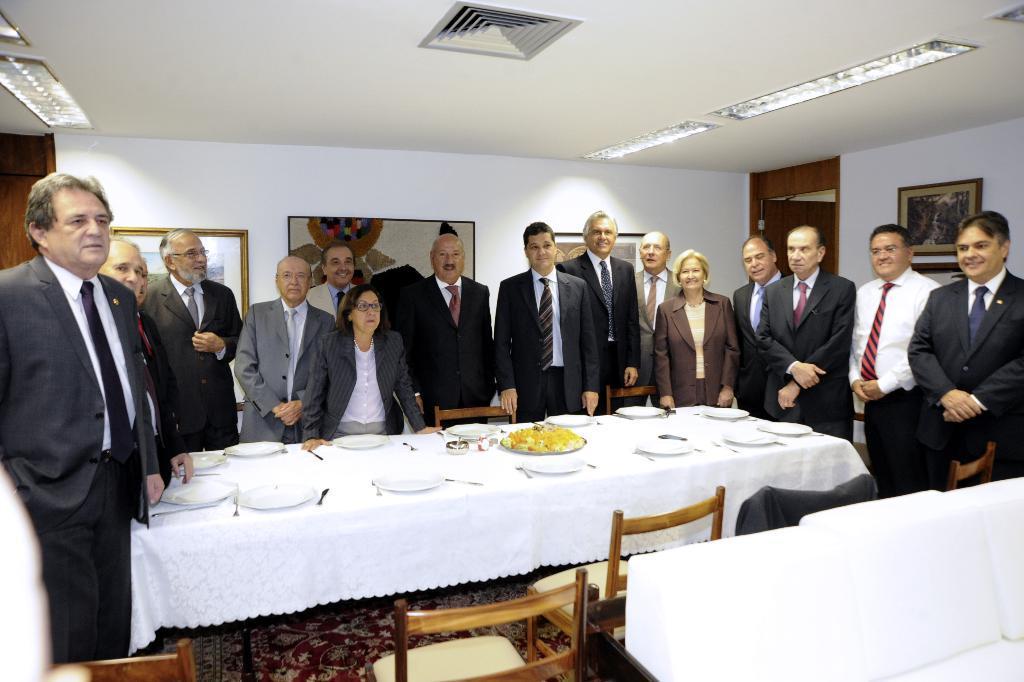Can you describe this image briefly? In the picture we can find a group of people near the table and chairs. In the background we can find a wall, a painting, photo frames. In the ceiling we can find a lights. People who are standing are wearing a blazers, ties and shirts. 